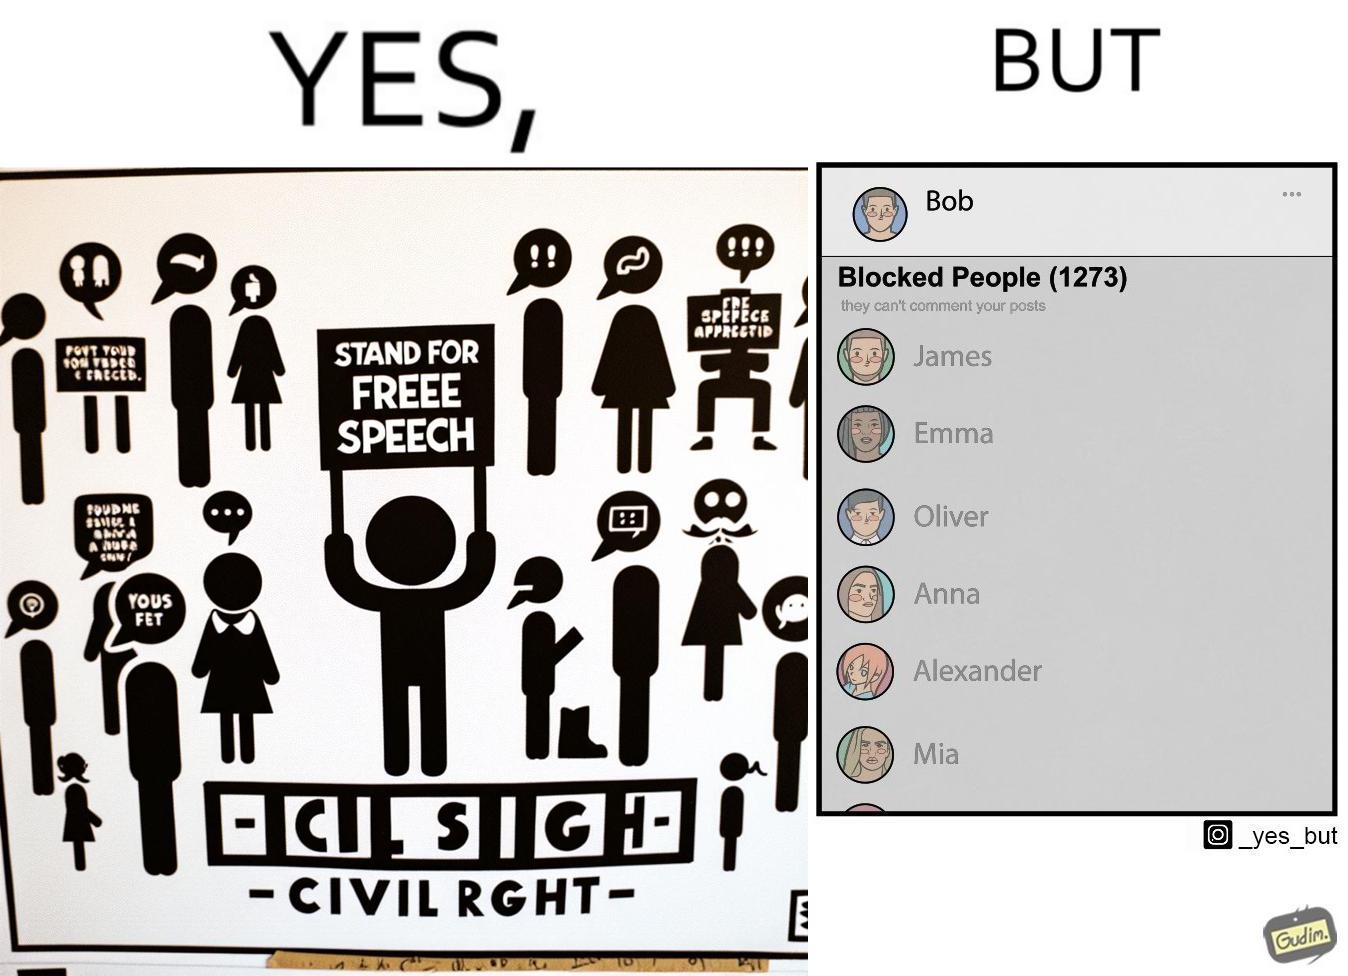Is there satirical content in this image? Yes, this image is satirical. 